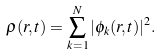<formula> <loc_0><loc_0><loc_500><loc_500>\rho ( { r } , t ) = \sum _ { k = 1 } ^ { N } | \phi _ { k } ( { r } , t ) | ^ { 2 } .</formula> 